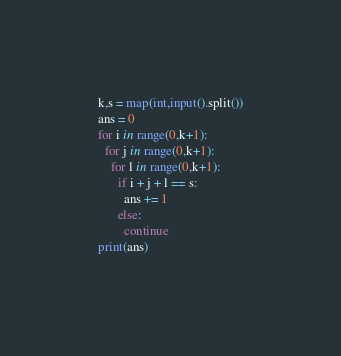Convert code to text. <code><loc_0><loc_0><loc_500><loc_500><_Python_>k,s = map(int,input().split())
ans = 0
for i in range(0,k+1):
  for j in range(0,k+1):
    for l in range(0,k+1):
      if i + j + l == s:
        ans += 1
      else:
        continue
print(ans)</code> 